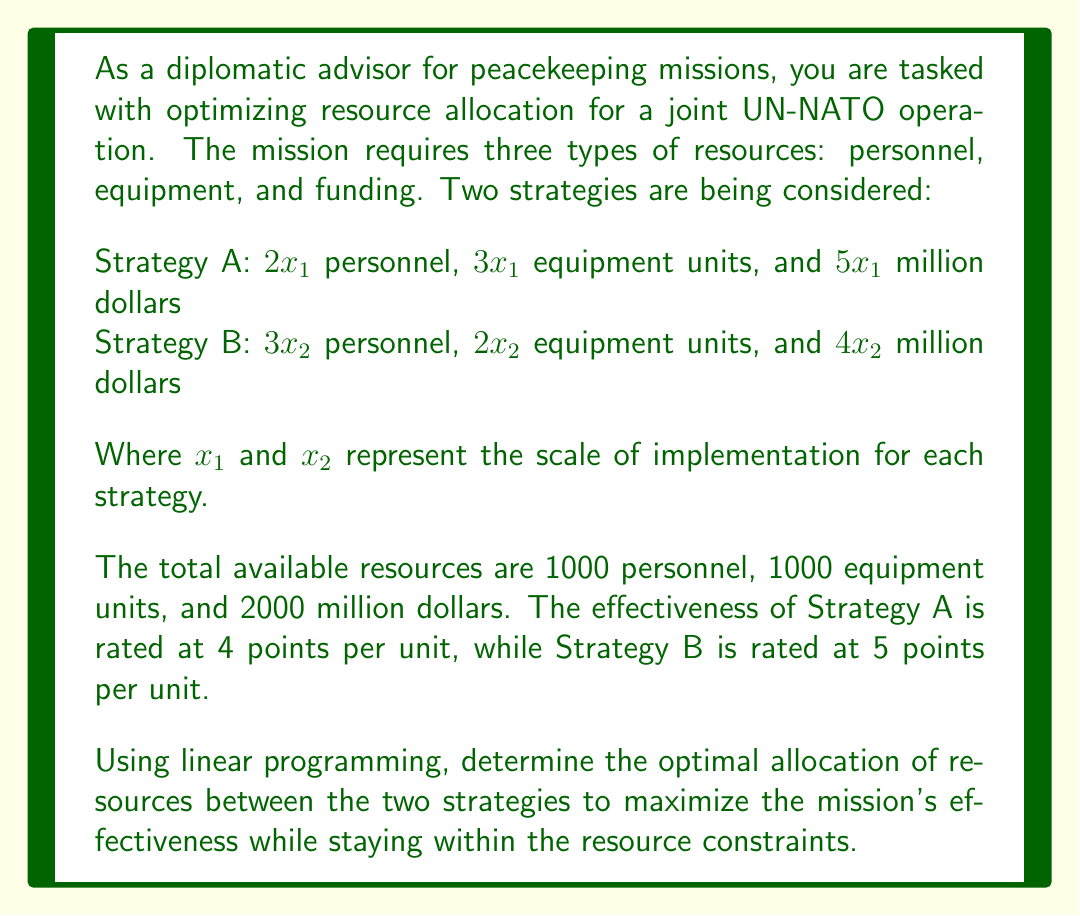What is the answer to this math problem? To solve this linear programming problem, we'll follow these steps:

1. Define the objective function
2. Identify the constraints
3. Set up the linear programming model
4. Solve the model using the simplex method or graphical method

Step 1: Define the objective function

The objective is to maximize the effectiveness of the mission. Let E be the total effectiveness:

$$E = 4x_1 + 5x_2$$

Step 2: Identify the constraints

Personnel constraint: $2x_1 + 3x_2 \leq 1000$
Equipment constraint: $3x_1 + 2x_2 \leq 1000$
Funding constraint: $5x_1 + 4x_2 \leq 2000$
Non-negativity constraints: $x_1 \geq 0, x_2 \geq 0$

Step 3: Set up the linear programming model

Maximize: $E = 4x_1 + 5x_2$
Subject to:
$2x_1 + 3x_2 \leq 1000$
$3x_1 + 2x_2 \leq 1000$
$5x_1 + 4x_2 \leq 2000$
$x_1 \geq 0, x_2 \geq 0$

Step 4: Solve the model

We can solve this using the graphical method since there are only two variables.

1. Plot the constraints:
   - $2x_1 + 3x_2 = 1000$
   - $3x_1 + 2x_2 = 1000$
   - $5x_1 + 4x_2 = 2000$

2. Identify the feasible region (the area that satisfies all constraints).

3. Find the corner points of the feasible region:
   (0, 0), (0, 333.33), (200, 400), (333.33, 0)

4. Evaluate the objective function at each corner point:
   E(0, 0) = 0
   E(0, 333.33) = 1666.65
   E(200, 400) = 2800
   E(333.33, 0) = 1333.32

The maximum value occurs at the point (200, 400).

Therefore, the optimal allocation is:
$x_1 = 200$ (units of Strategy A)
$x_2 = 400$ (units of Strategy B)

The maximum effectiveness achieved is 2800 points.
Answer: The optimal resource allocation is 200 units of Strategy A and 400 units of Strategy B, resulting in a maximum effectiveness of 2800 points. 